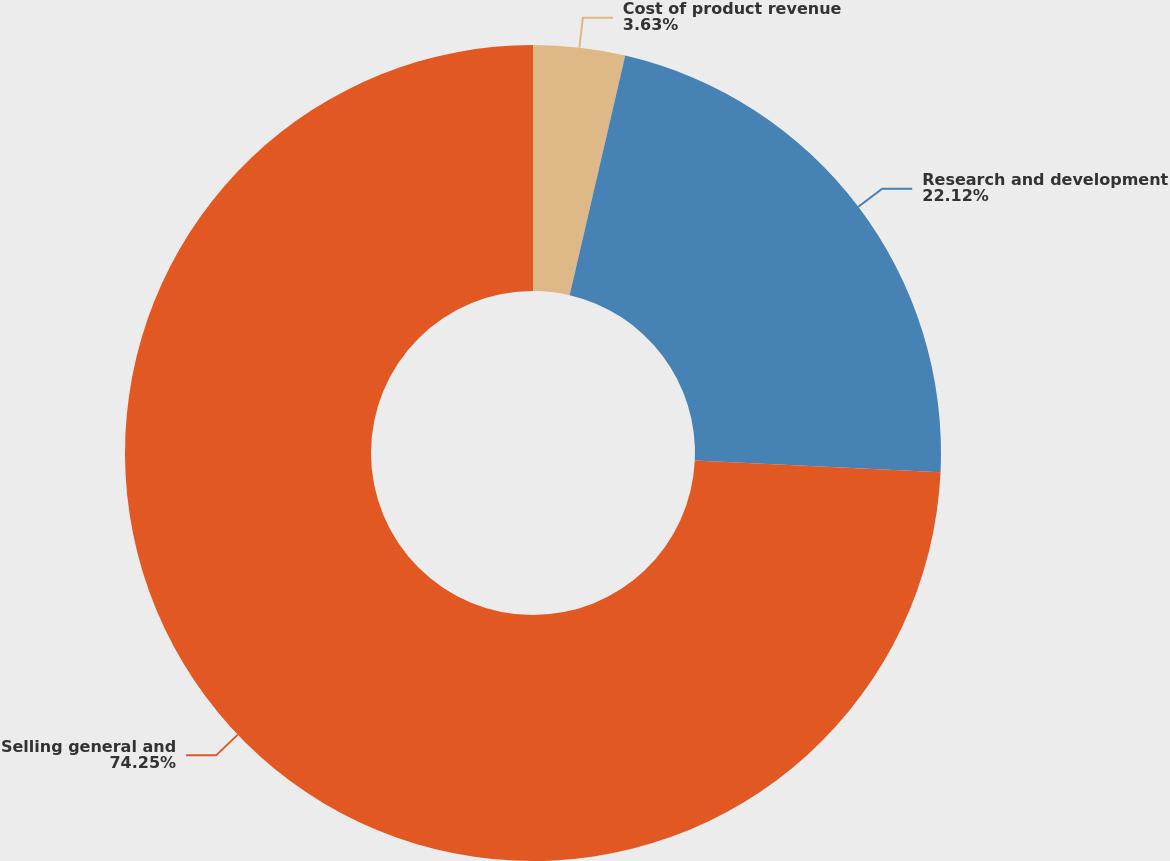Convert chart. <chart><loc_0><loc_0><loc_500><loc_500><pie_chart><fcel>Cost of product revenue<fcel>Research and development<fcel>Selling general and<nl><fcel>3.63%<fcel>22.12%<fcel>74.26%<nl></chart> 